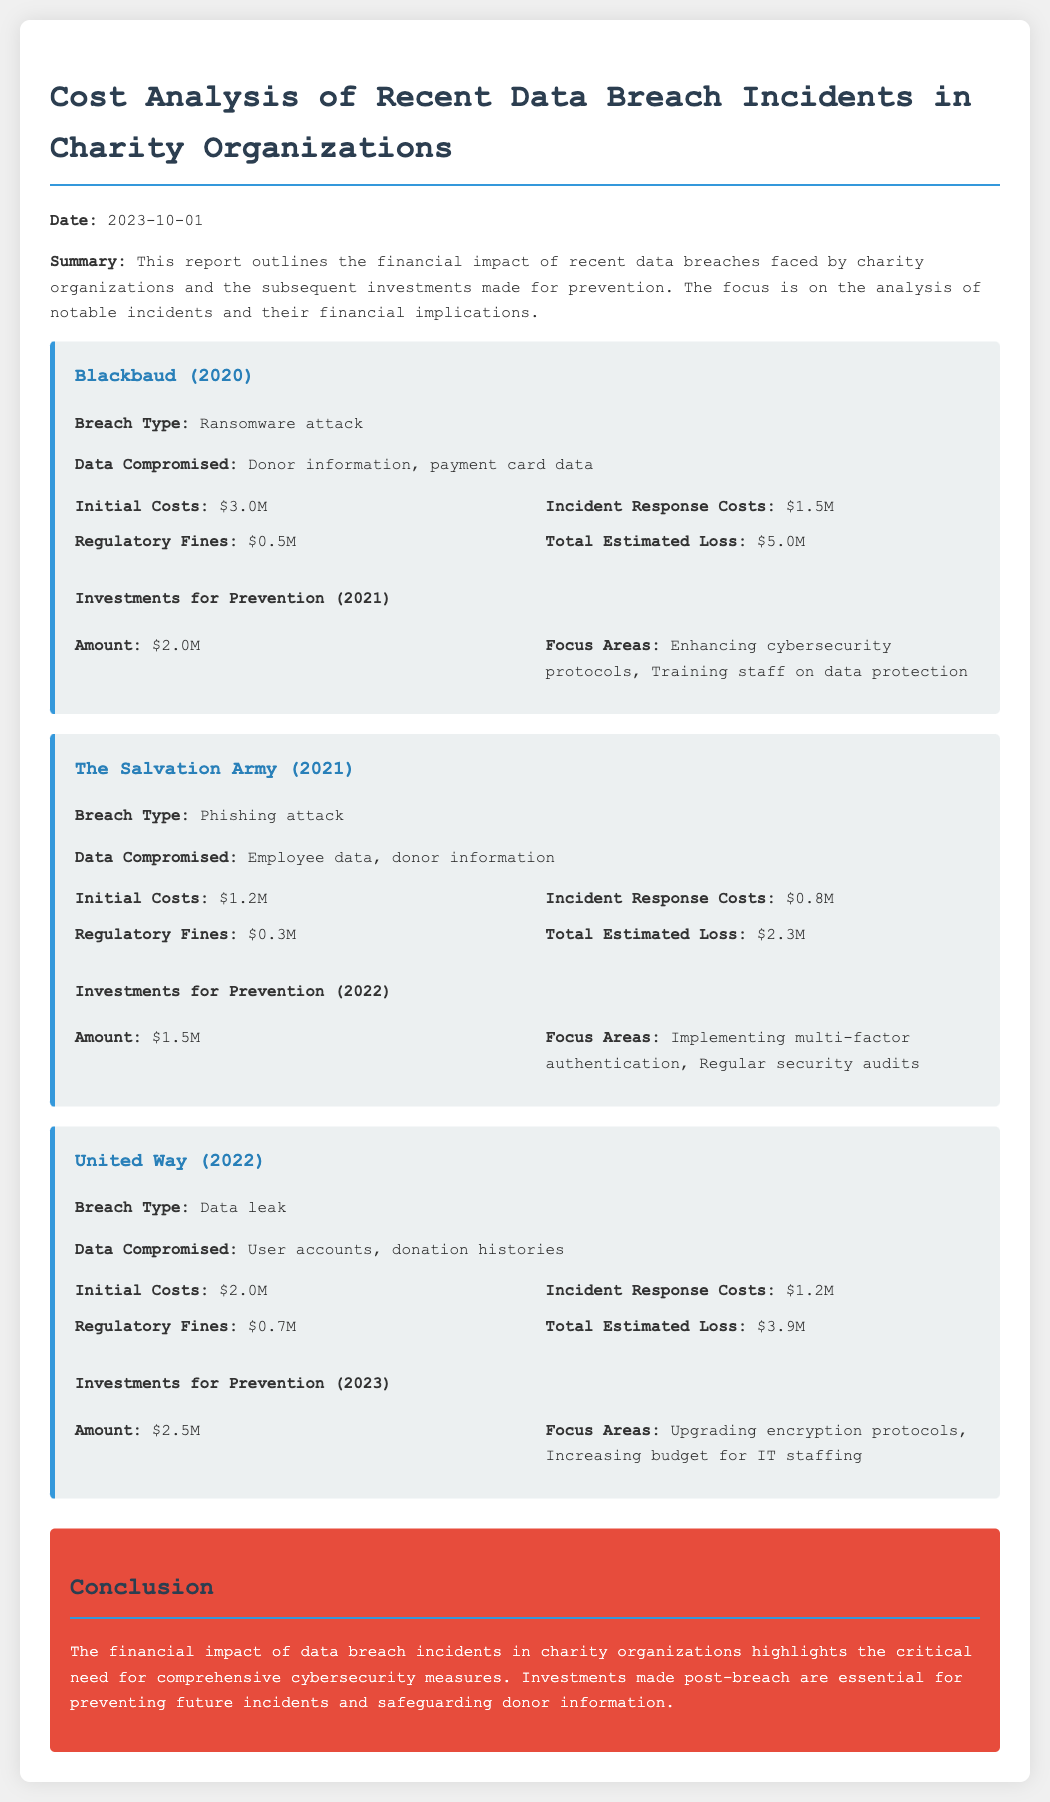What was the total estimated loss for Blackbaud? The total estimated loss is detailed in the financial impact section for Blackbaud and is $5.0M.
Answer: $5.0M What investment amount was made after the breach at The Salvation Army? The investment amount is listed under the investments section for The Salvation Army and is $1.5M.
Answer: $1.5M What was the breach type for the United Way incident? The breach type for United Way is specified in the document as a data leak.
Answer: Data leak How much was spent on incident response costs by Blackbaud? Incident response costs are outlined in the financial impact section for Blackbaud and amount to $1.5M.
Answer: $1.5M What focus area was emphasized in the prevention investment made by United Way? The focus areas for the prevention investment made by United Way include upgrading encryption protocols.
Answer: Upgrading encryption protocols What was the initial cost of the breach for The Salvation Army? The initial cost for The Salvation Army is mentioned in the financial impact section as $1.2M.
Answer: $1.2M Which year did Blackbaud have their data breach? The year of Blackbaud's breach is mentioned in the document as 2020.
Answer: 2020 What was the regulatory fine for the United Way data breach? The regulatory fine for United Way's data breach is provided in the financial impact section and is $0.7M.
Answer: $0.7M What significant need does the conclusion highlight? The conclusion emphasizes the critical need for comprehensive cybersecurity measures, indicated in the final paragraph.
Answer: Comprehensive cybersecurity measures 